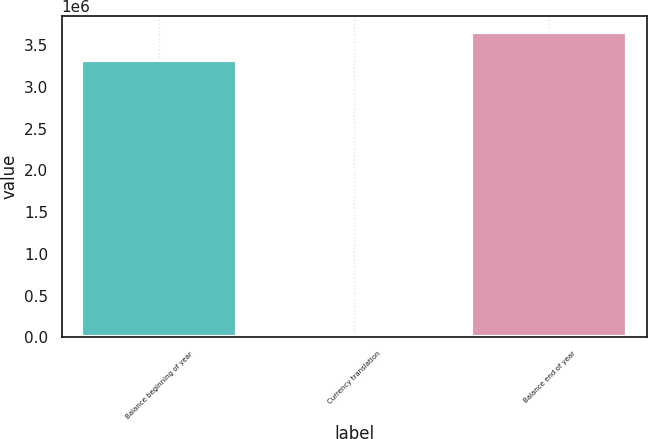Convert chart to OTSL. <chart><loc_0><loc_0><loc_500><loc_500><bar_chart><fcel>Balance beginning of year<fcel>Currency translation<fcel>Balance end of year<nl><fcel>3.32647e+06<fcel>26058<fcel>3.66137e+06<nl></chart> 